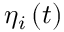Convert formula to latex. <formula><loc_0><loc_0><loc_500><loc_500>\eta _ { i } \left ( t \right )</formula> 